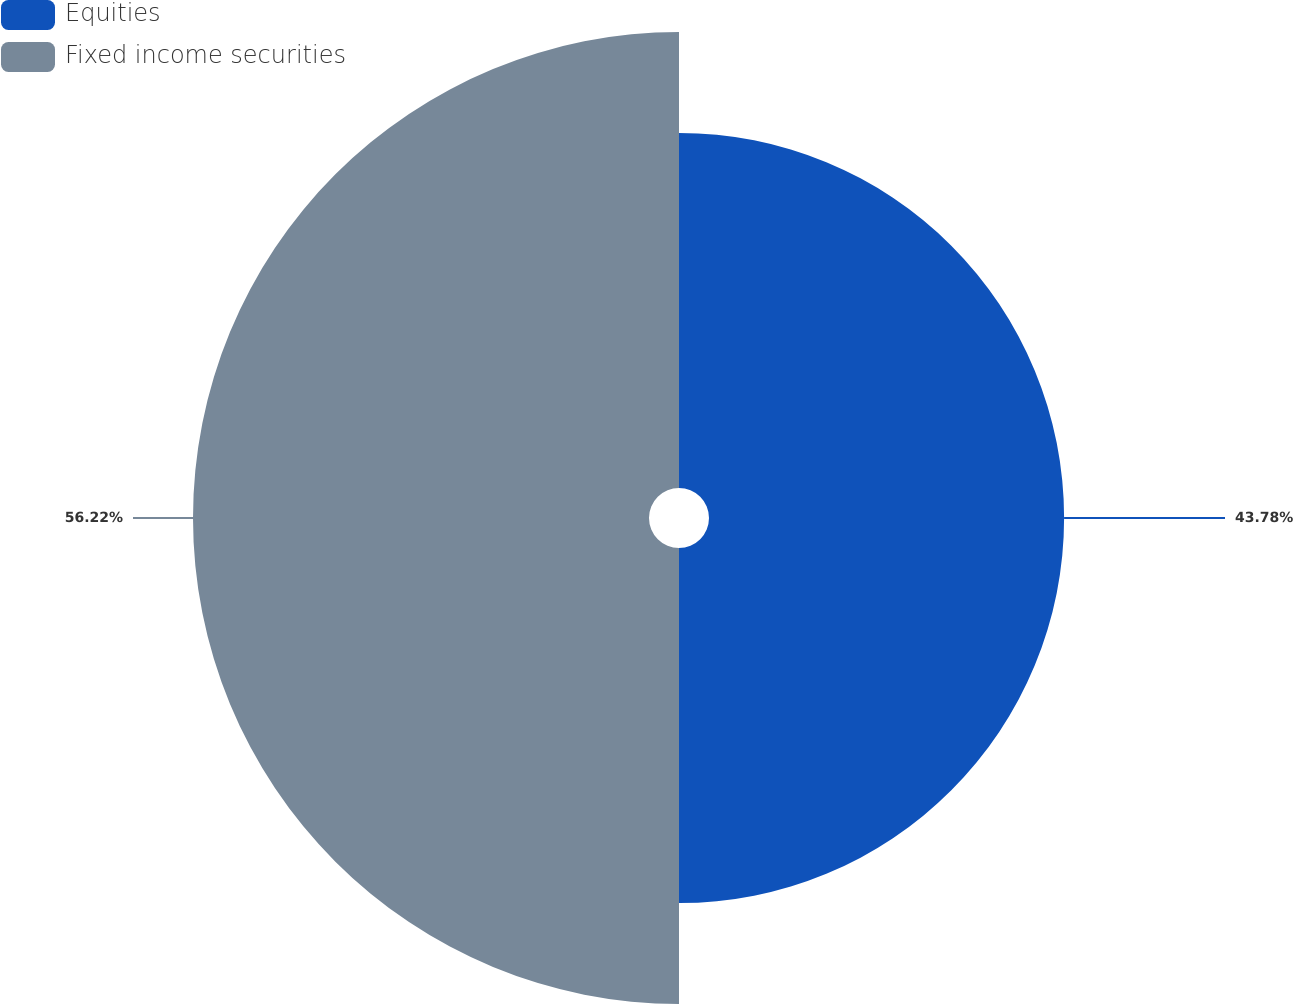<chart> <loc_0><loc_0><loc_500><loc_500><pie_chart><fcel>Equities<fcel>Fixed income securities<nl><fcel>43.78%<fcel>56.22%<nl></chart> 